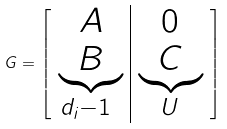Convert formula to latex. <formula><loc_0><loc_0><loc_500><loc_500>G = \left [ \begin{array} { c | c } A & 0 \\ \underbrace { B } _ { d _ { i } - 1 \ } & \underbrace { C } _ { U } \end{array} \right ]</formula> 